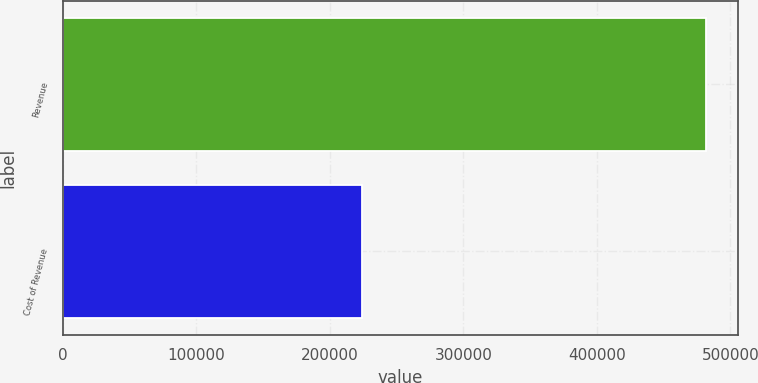Convert chart to OTSL. <chart><loc_0><loc_0><loc_500><loc_500><bar_chart><fcel>Revenue<fcel>Cost of Revenue<nl><fcel>481625<fcel>224214<nl></chart> 